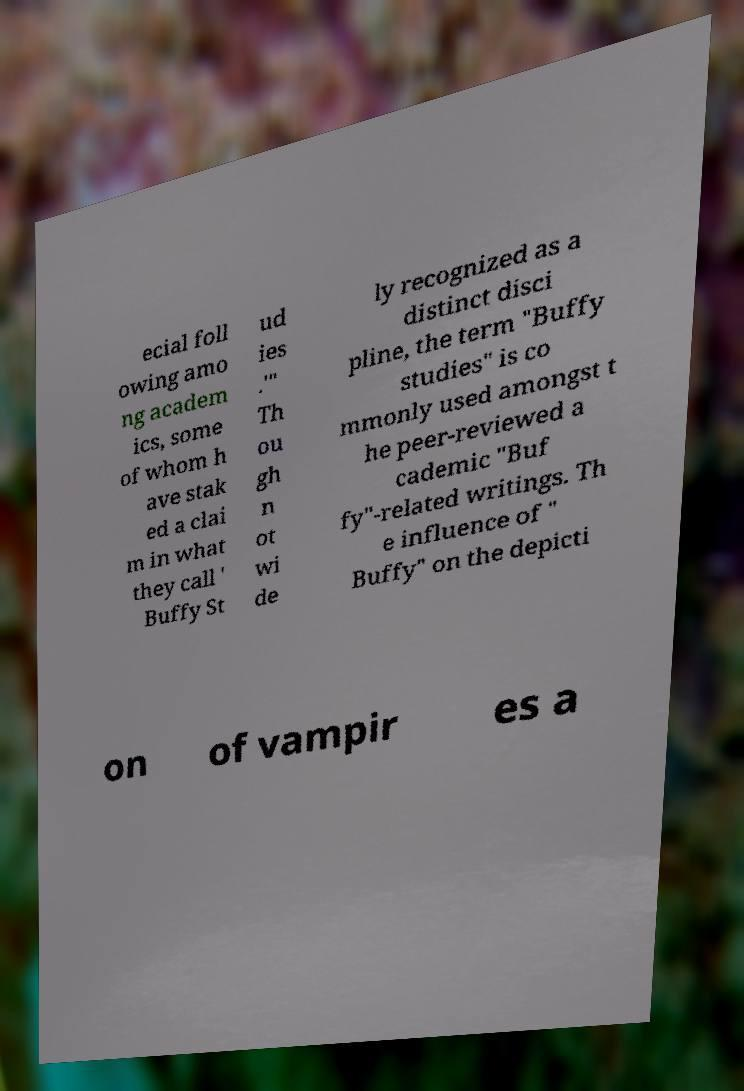Please read and relay the text visible in this image. What does it say? ecial foll owing amo ng academ ics, some of whom h ave stak ed a clai m in what they call ' Buffy St ud ies .'" Th ou gh n ot wi de ly recognized as a distinct disci pline, the term "Buffy studies" is co mmonly used amongst t he peer-reviewed a cademic "Buf fy"-related writings. Th e influence of " Buffy" on the depicti on of vampir es a 